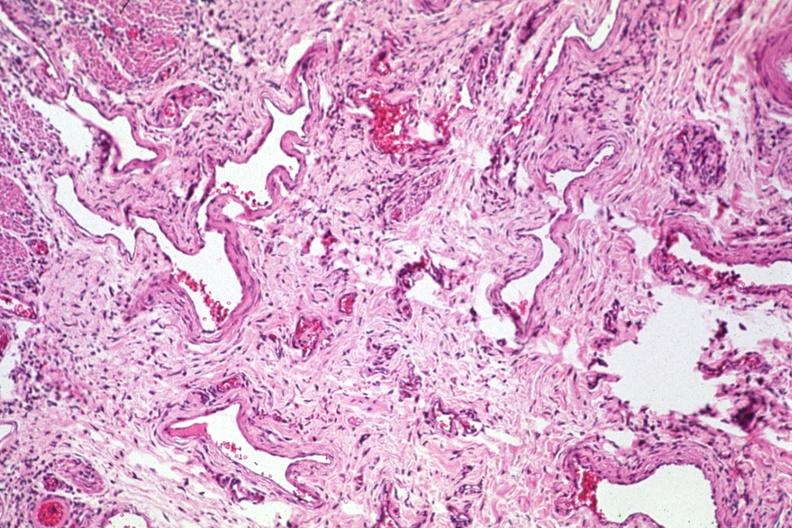s gastrointestinal present?
Answer the question using a single word or phrase. Yes 